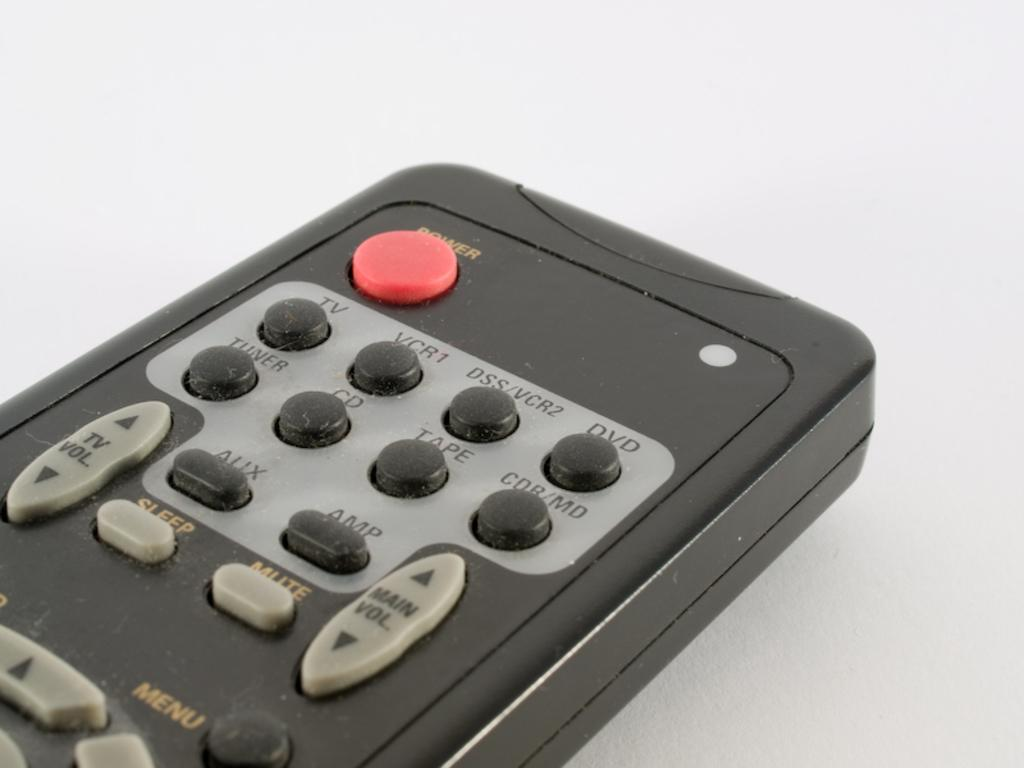<image>
Share a concise interpretation of the image provided. Black remote control with red button at top that says power. 